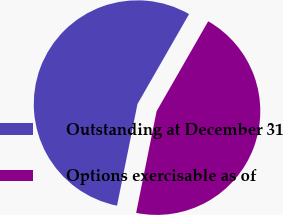Convert chart. <chart><loc_0><loc_0><loc_500><loc_500><pie_chart><fcel>Outstanding at December 31<fcel>Options exercisable as of<nl><fcel>55.13%<fcel>44.87%<nl></chart> 